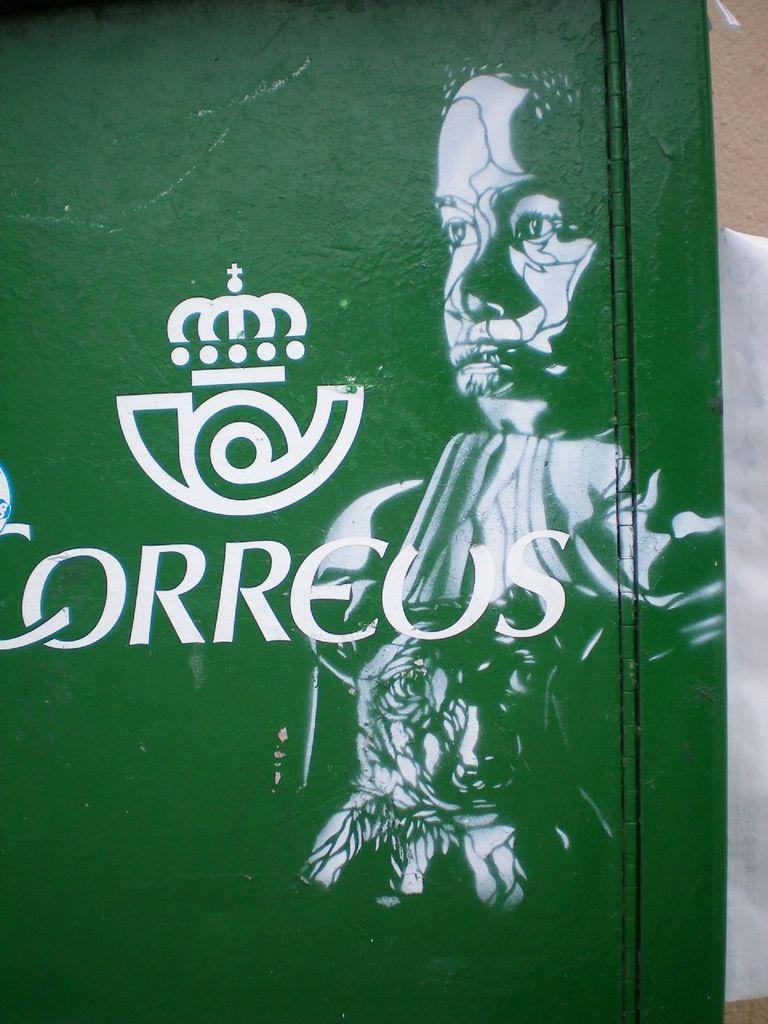What is the main subject of the painting in the image? There is a painting of a person in the image. What else can be seen in the painting besides the person? There is something else depicted in the painting. What color is the wall in the image? There is a green color wall in the image. What is written on the green color wall? There is something written on the green color wall. How many books can be seen on the jelly in the image? There is no jelly or books present in the image. 